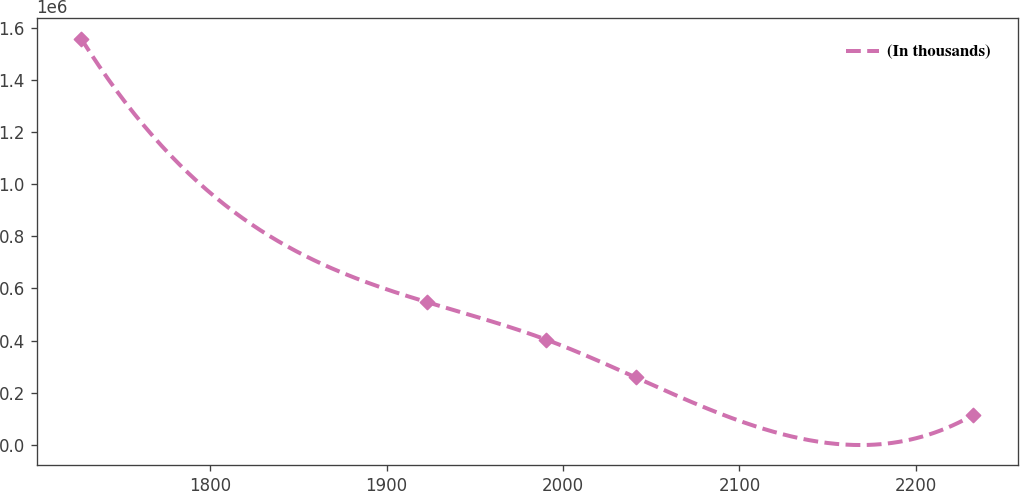Convert chart. <chart><loc_0><loc_0><loc_500><loc_500><line_chart><ecel><fcel>(In thousands)<nl><fcel>1726.94<fcel>1.55933e+06<nl><fcel>1922.77<fcel>547792<nl><fcel>1990.56<fcel>403287<nl><fcel>2041.1<fcel>258781<nl><fcel>2232.38<fcel>114276<nl></chart> 